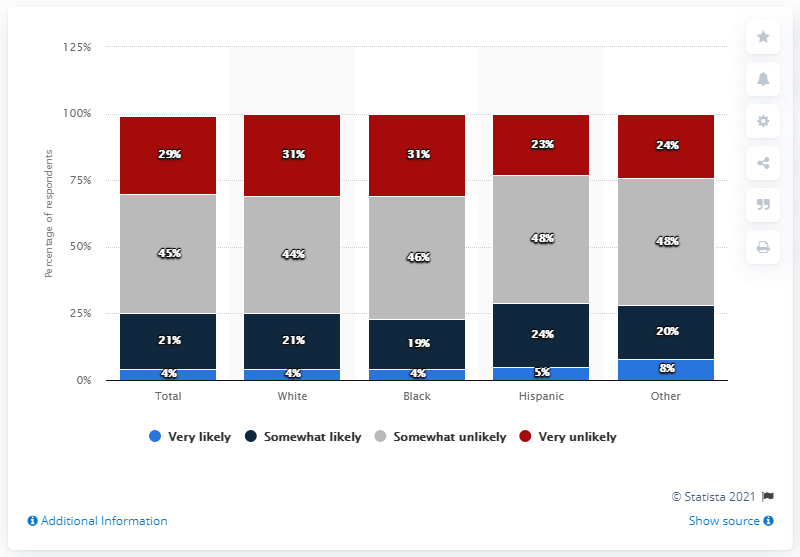Highlight a few significant elements in this photo. The maximum value of the blue bar is 8.. The maximum value of the red bar and the minimum value of the blue bar are both 27. 